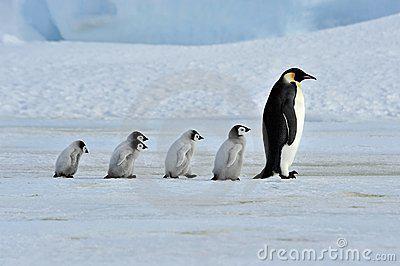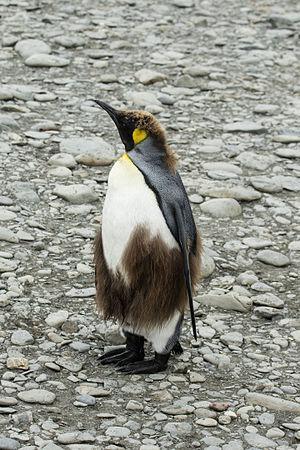The first image is the image on the left, the second image is the image on the right. Considering the images on both sides, is "The penguins in the image on the right are walking across the snow." valid? Answer yes or no. No. The first image is the image on the left, the second image is the image on the right. For the images displayed, is the sentence "An image shows a row of no more than six upright penguins, all facing right." factually correct? Answer yes or no. Yes. 